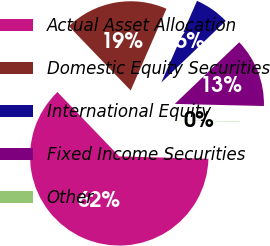Convert chart to OTSL. <chart><loc_0><loc_0><loc_500><loc_500><pie_chart><fcel>Actual Asset Allocation<fcel>Domestic Equity Securities<fcel>International Equity<fcel>Fixed Income Securities<fcel>Other<nl><fcel>62.37%<fcel>18.75%<fcel>6.29%<fcel>12.52%<fcel>0.06%<nl></chart> 